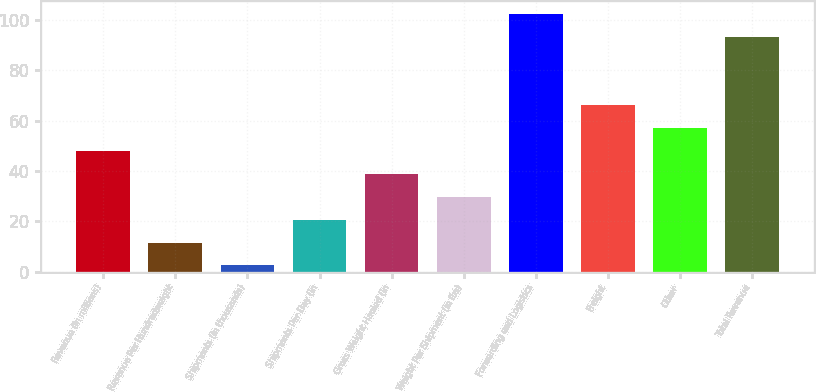Convert chart. <chart><loc_0><loc_0><loc_500><loc_500><bar_chart><fcel>Revenue (in millions)<fcel>Revenue Per Hundredweight<fcel>Shipments (in thousands)<fcel>Shipments Per Day (in<fcel>Gross Weight Hauled (in<fcel>Weight Per Shipment (in lbs)<fcel>Forwarding and Logistics<fcel>Freight<fcel>Other<fcel>Total Revenue<nl><fcel>47.9<fcel>11.58<fcel>2.5<fcel>20.66<fcel>38.82<fcel>29.74<fcel>102.38<fcel>66.06<fcel>56.98<fcel>93.3<nl></chart> 